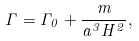Convert formula to latex. <formula><loc_0><loc_0><loc_500><loc_500>\Gamma = \Gamma _ { 0 } + \frac { m } { a ^ { 3 } H ^ { 2 } } ,</formula> 